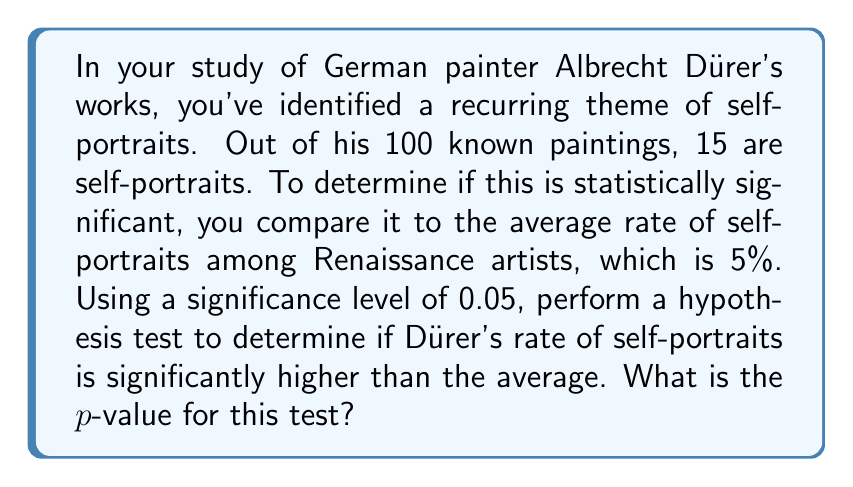Give your solution to this math problem. To solve this problem, we'll use a one-tailed binomial test. We're testing if Dürer's rate is significantly higher than the average, so this is a right-tailed test.

Step 1: Define the null and alternative hypotheses
$H_0: p = 0.05$ (Dürer's rate of self-portraits is equal to the average)
$H_a: p > 0.05$ (Dürer's rate of self-portraits is higher than the average)

Step 2: Calculate the test statistic
Observed number of successes: $X = 15$
Total number of trials: $n = 100$
Probability of success under $H_0$: $p_0 = 0.05$

Step 3: Calculate the p-value
The p-value is the probability of observing 15 or more self-portraits out of 100 paintings, given that the true rate is 5%.

$$P(X \geq 15 | n = 100, p = 0.05) = 1 - P(X \leq 14 | n = 100, p = 0.05)$$

We can calculate this using the cumulative binomial distribution function:

$$p\text{-value} = 1 - \sum_{k=0}^{14} \binom{100}{k} (0.05)^k (0.95)^{100-k}$$

Using a statistical software or calculator, we find:

$$p\text{-value} \approx 1.65 \times 10^{-5}$$

Step 4: Compare the p-value to the significance level
Since $1.65 \times 10^{-5} < 0.05$, we reject the null hypothesis.
Answer: $1.65 \times 10^{-5}$ 